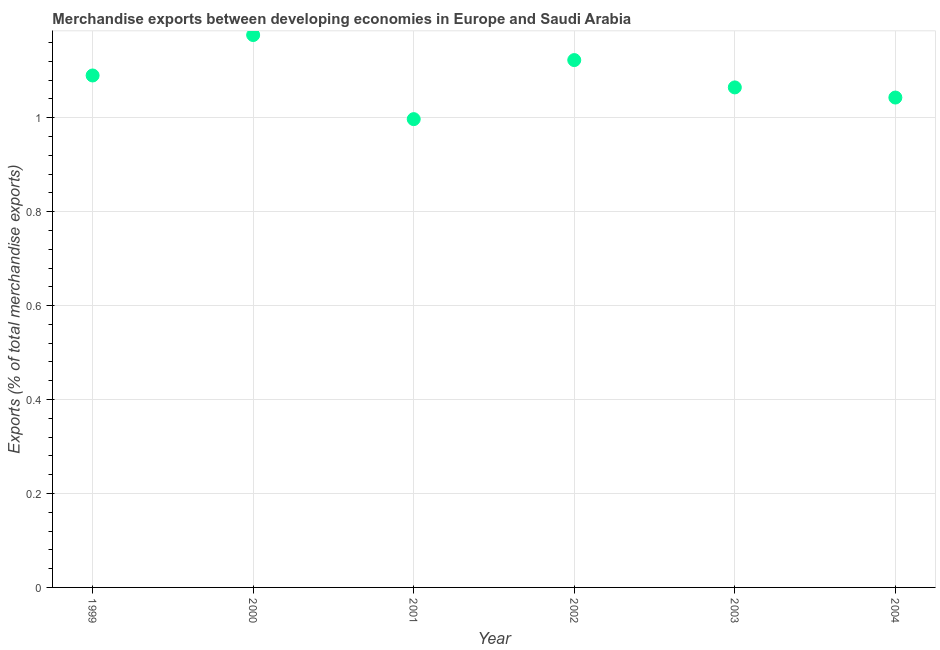What is the merchandise exports in 2003?
Keep it short and to the point. 1.06. Across all years, what is the maximum merchandise exports?
Offer a terse response. 1.18. Across all years, what is the minimum merchandise exports?
Your answer should be compact. 1. In which year was the merchandise exports maximum?
Give a very brief answer. 2000. What is the sum of the merchandise exports?
Offer a very short reply. 6.49. What is the difference between the merchandise exports in 1999 and 2004?
Offer a very short reply. 0.05. What is the average merchandise exports per year?
Keep it short and to the point. 1.08. What is the median merchandise exports?
Ensure brevity in your answer.  1.08. In how many years, is the merchandise exports greater than 0.28 %?
Provide a short and direct response. 6. What is the ratio of the merchandise exports in 2000 to that in 2004?
Ensure brevity in your answer.  1.13. Is the merchandise exports in 2000 less than that in 2002?
Provide a short and direct response. No. Is the difference between the merchandise exports in 2000 and 2001 greater than the difference between any two years?
Provide a short and direct response. Yes. What is the difference between the highest and the second highest merchandise exports?
Your answer should be very brief. 0.05. What is the difference between the highest and the lowest merchandise exports?
Make the answer very short. 0.18. Does the merchandise exports monotonically increase over the years?
Provide a succinct answer. No. How many dotlines are there?
Your answer should be very brief. 1. What is the difference between two consecutive major ticks on the Y-axis?
Give a very brief answer. 0.2. Does the graph contain any zero values?
Make the answer very short. No. What is the title of the graph?
Give a very brief answer. Merchandise exports between developing economies in Europe and Saudi Arabia. What is the label or title of the X-axis?
Offer a very short reply. Year. What is the label or title of the Y-axis?
Offer a very short reply. Exports (% of total merchandise exports). What is the Exports (% of total merchandise exports) in 1999?
Provide a succinct answer. 1.09. What is the Exports (% of total merchandise exports) in 2000?
Offer a terse response. 1.18. What is the Exports (% of total merchandise exports) in 2001?
Your answer should be very brief. 1. What is the Exports (% of total merchandise exports) in 2002?
Offer a very short reply. 1.12. What is the Exports (% of total merchandise exports) in 2003?
Keep it short and to the point. 1.06. What is the Exports (% of total merchandise exports) in 2004?
Your response must be concise. 1.04. What is the difference between the Exports (% of total merchandise exports) in 1999 and 2000?
Offer a terse response. -0.09. What is the difference between the Exports (% of total merchandise exports) in 1999 and 2001?
Keep it short and to the point. 0.09. What is the difference between the Exports (% of total merchandise exports) in 1999 and 2002?
Provide a succinct answer. -0.03. What is the difference between the Exports (% of total merchandise exports) in 1999 and 2003?
Give a very brief answer. 0.03. What is the difference between the Exports (% of total merchandise exports) in 1999 and 2004?
Keep it short and to the point. 0.05. What is the difference between the Exports (% of total merchandise exports) in 2000 and 2001?
Offer a very short reply. 0.18. What is the difference between the Exports (% of total merchandise exports) in 2000 and 2002?
Provide a short and direct response. 0.05. What is the difference between the Exports (% of total merchandise exports) in 2000 and 2003?
Ensure brevity in your answer.  0.11. What is the difference between the Exports (% of total merchandise exports) in 2000 and 2004?
Your answer should be compact. 0.13. What is the difference between the Exports (% of total merchandise exports) in 2001 and 2002?
Provide a succinct answer. -0.13. What is the difference between the Exports (% of total merchandise exports) in 2001 and 2003?
Make the answer very short. -0.07. What is the difference between the Exports (% of total merchandise exports) in 2001 and 2004?
Your answer should be very brief. -0.05. What is the difference between the Exports (% of total merchandise exports) in 2002 and 2003?
Give a very brief answer. 0.06. What is the difference between the Exports (% of total merchandise exports) in 2002 and 2004?
Provide a short and direct response. 0.08. What is the difference between the Exports (% of total merchandise exports) in 2003 and 2004?
Your answer should be very brief. 0.02. What is the ratio of the Exports (% of total merchandise exports) in 1999 to that in 2000?
Your response must be concise. 0.93. What is the ratio of the Exports (% of total merchandise exports) in 1999 to that in 2001?
Your response must be concise. 1.09. What is the ratio of the Exports (% of total merchandise exports) in 1999 to that in 2002?
Offer a very short reply. 0.97. What is the ratio of the Exports (% of total merchandise exports) in 1999 to that in 2004?
Make the answer very short. 1.04. What is the ratio of the Exports (% of total merchandise exports) in 2000 to that in 2001?
Provide a short and direct response. 1.18. What is the ratio of the Exports (% of total merchandise exports) in 2000 to that in 2002?
Offer a terse response. 1.05. What is the ratio of the Exports (% of total merchandise exports) in 2000 to that in 2003?
Offer a very short reply. 1.1. What is the ratio of the Exports (% of total merchandise exports) in 2000 to that in 2004?
Keep it short and to the point. 1.13. What is the ratio of the Exports (% of total merchandise exports) in 2001 to that in 2002?
Your response must be concise. 0.89. What is the ratio of the Exports (% of total merchandise exports) in 2001 to that in 2003?
Keep it short and to the point. 0.94. What is the ratio of the Exports (% of total merchandise exports) in 2001 to that in 2004?
Make the answer very short. 0.96. What is the ratio of the Exports (% of total merchandise exports) in 2002 to that in 2003?
Make the answer very short. 1.05. What is the ratio of the Exports (% of total merchandise exports) in 2002 to that in 2004?
Offer a terse response. 1.08. What is the ratio of the Exports (% of total merchandise exports) in 2003 to that in 2004?
Provide a short and direct response. 1.02. 